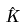<formula> <loc_0><loc_0><loc_500><loc_500>\hat { K }</formula> 